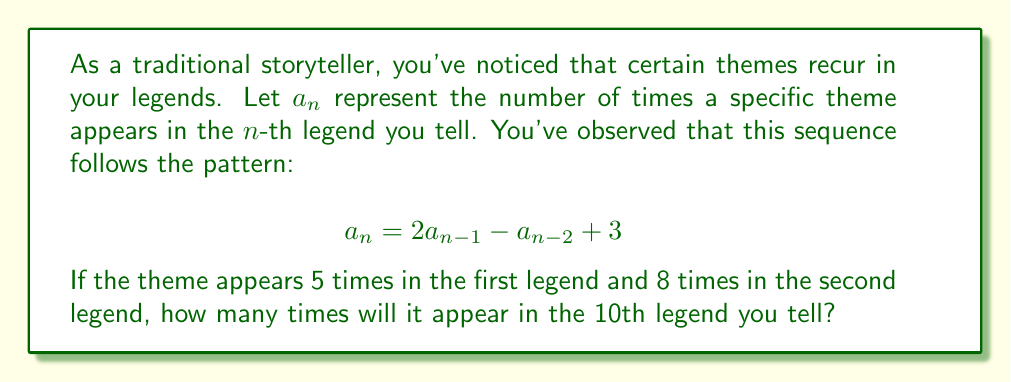Teach me how to tackle this problem. To solve this problem, we need to use the given recurrence relation and initial conditions to find $a_{10}$. Let's approach this step-by-step:

1) We're given:
   $a_1 = 5$ (first legend)
   $a_2 = 8$ (second legend)
   The recurrence relation: $a_n = 2a_{n-1} - a_{n-2} + 3$

2) Let's calculate the next few terms:

   For $n = 3$:
   $a_3 = 2a_2 - a_1 + 3 = 2(8) - 5 + 3 = 16 - 5 + 3 = 14$

   For $n = 4$:
   $a_4 = 2a_3 - a_2 + 3 = 2(14) - 8 + 3 = 28 - 8 + 3 = 23$

   For $n = 5$:
   $a_5 = 2a_4 - a_3 + 3 = 2(23) - 14 + 3 = 46 - 14 + 3 = 35$

3) We can continue this process until we reach $a_{10}$, but let's look for a pattern:

   $a_1 = 5$
   $a_2 = 8$
   $a_3 = 14$
   $a_4 = 23$
   $a_5 = 35$

4) We can see that the difference between consecutive terms is increasing by 3 each time:

   $8 - 5 = 3$
   $14 - 8 = 6$
   $23 - 14 = 9$
   $35 - 23 = 12$

5) This suggests that the sequence follows a quadratic pattern. In fact, we can prove that the general term is:

   $$a_n = \frac{3n^2 + 5n - 3}{2}$$

6) To verify, let's check if this satisfies our recurrence relation:

   $a_n = \frac{3n^2 + 5n - 3}{2}$
   $a_{n-1} = \frac{3(n-1)^2 + 5(n-1) - 3}{2} = \frac{3n^2 - 9n + 6 + 5n - 5 - 3}{2} = \frac{3n^2 - 4n - 2}{2}$
   $a_{n-2} = \frac{3(n-2)^2 + 5(n-2) - 3}{2} = \frac{3n^2 - 18n + 24 + 5n - 10 - 3}{2} = \frac{3n^2 - 13n + 11}{2}$

   Now, let's substitute these into our recurrence relation:

   $2a_{n-1} - a_{n-2} + 3 = 2(\frac{3n^2 - 4n - 2}{2}) - \frac{3n^2 - 13n + 11}{2} + 3$
                            $= (3n^2 - 4n - 2) - \frac{3n^2 - 13n + 11}{2} + 3$
                            $= 3n^2 - 4n - 2 - \frac{3n^2 - 13n + 11}{2} + 3$
                            $= \frac{6n^2 - 8n - 4 - 3n^2 + 13n - 11 + 6}{2}$
                            $= \frac{3n^2 + 5n - 3}{2} = a_n$

   This confirms that our general term is correct.

7) Now we can simply substitute $n = 10$ into our general term:

   $a_{10} = \frac{3(10)^2 + 5(10) - 3}{2} = \frac{300 + 50 - 3}{2} = \frac{347}{2}$
Answer: The theme will appear $\frac{347}{2} = 173.5$ times in the 10th legend. Since the number of appearances must be a whole number, we can interpret this as 173 or 174 times, depending on how we round the result. 